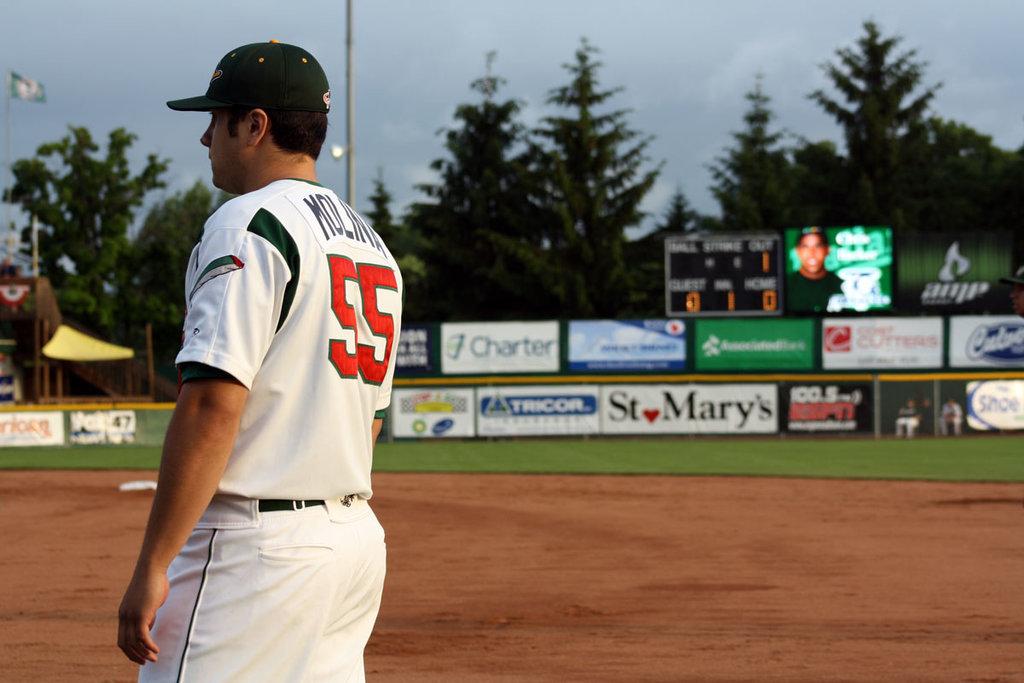How many outs are there?
Make the answer very short. 1. 